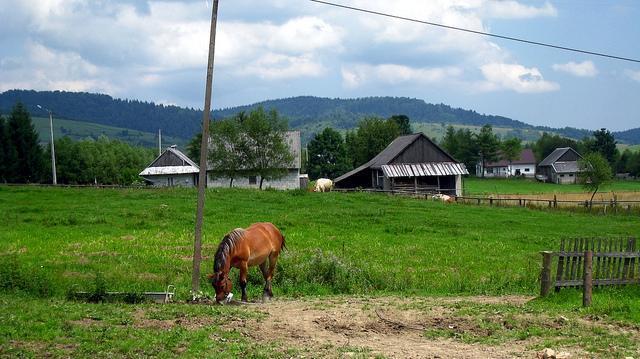What is the large pole near the horse supplying to the homes?
Pick the correct solution from the four options below to address the question.
Options: Electricity, milk, light, fruit. Electricity. 